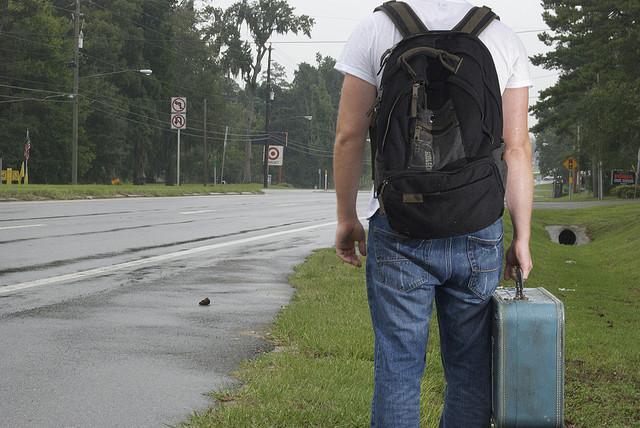How many suitcases can be seen?
Give a very brief answer. 1. How many backpacks are there?
Give a very brief answer. 1. How many kites are in the image?
Give a very brief answer. 0. 